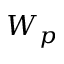Convert formula to latex. <formula><loc_0><loc_0><loc_500><loc_500>W _ { p }</formula> 